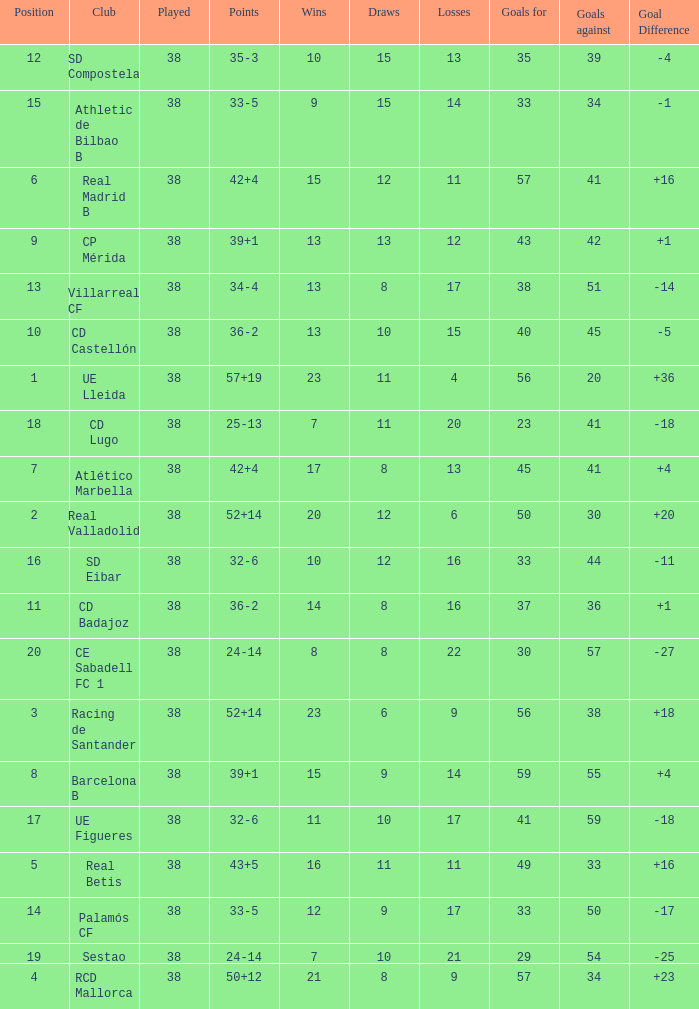What is the highest number played with a goal difference less than -27? None. 